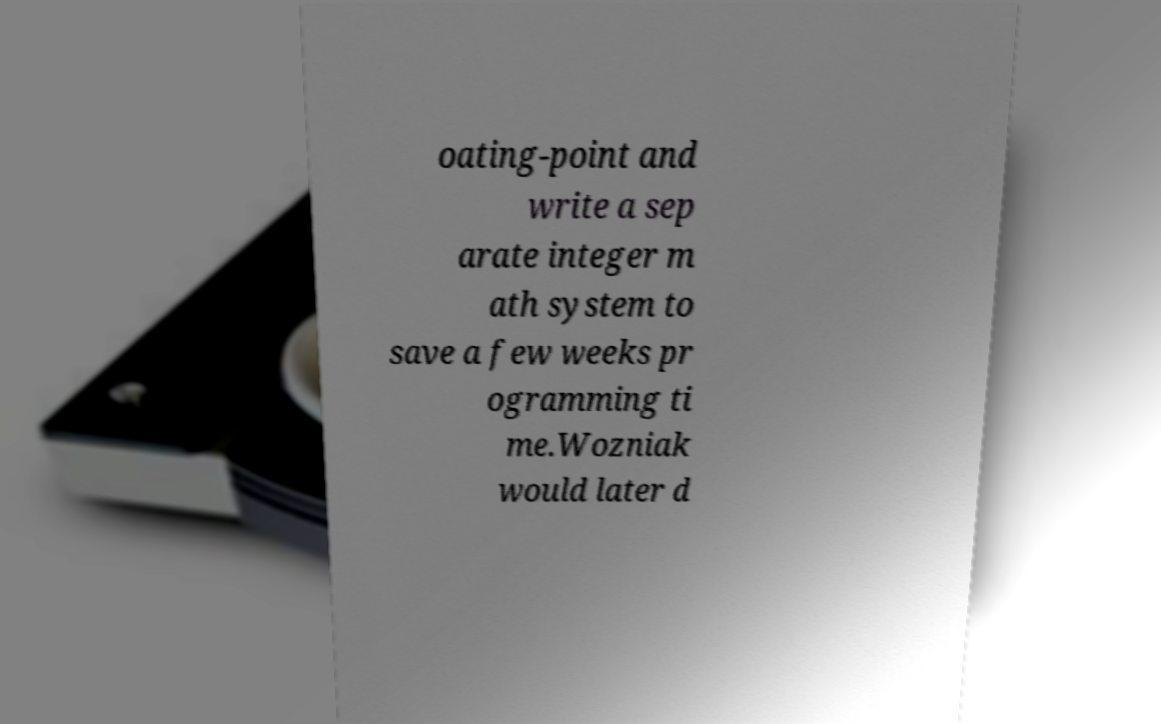There's text embedded in this image that I need extracted. Can you transcribe it verbatim? oating-point and write a sep arate integer m ath system to save a few weeks pr ogramming ti me.Wozniak would later d 